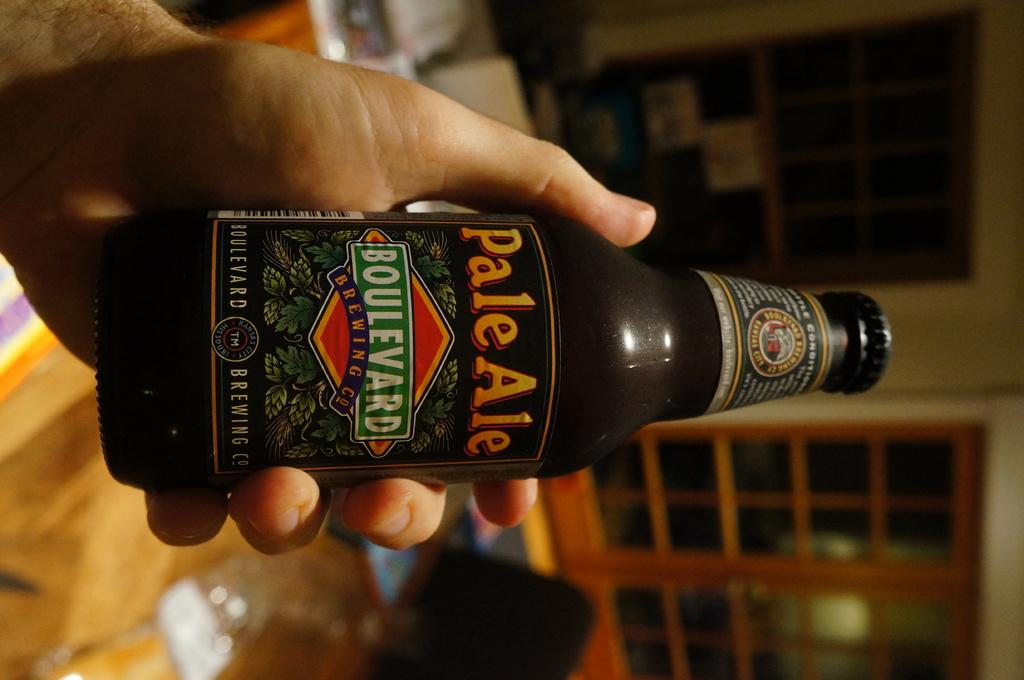Provide a one-sentence caption for the provided image. A bottle of Pale Ale is being held in front of a red door. 